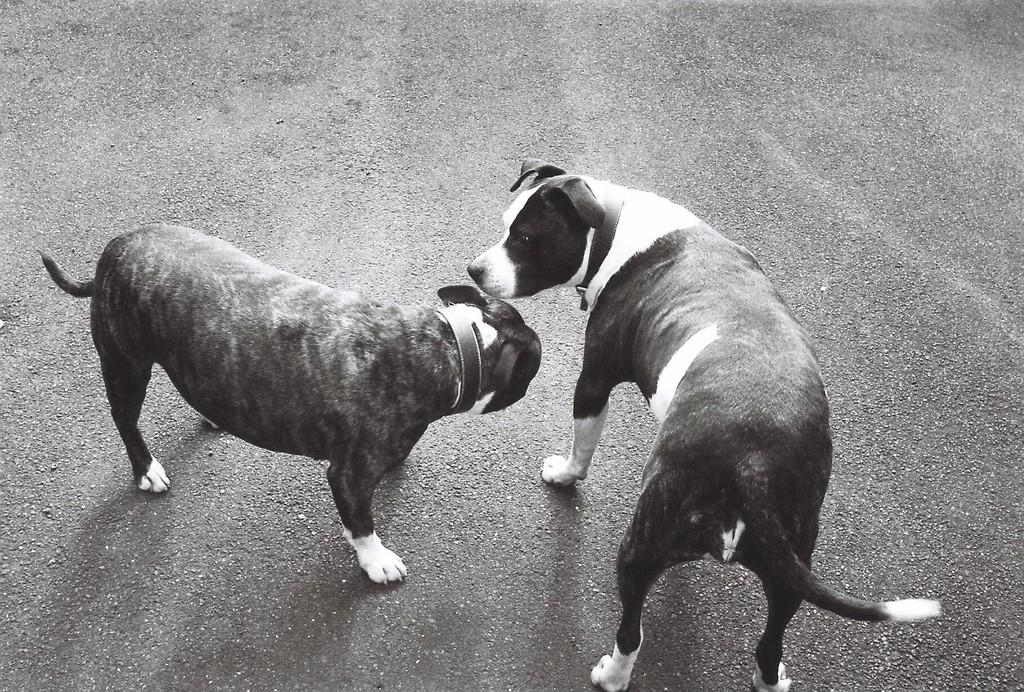What type of surface is visible in the image? There is a road surface in the image. What animals can be seen on the road surface? Two dogs are standing together on the road surface. What type of fruit is the dogs holding in the image? There is no fruit present in the image, and the dogs are not holding anything. 